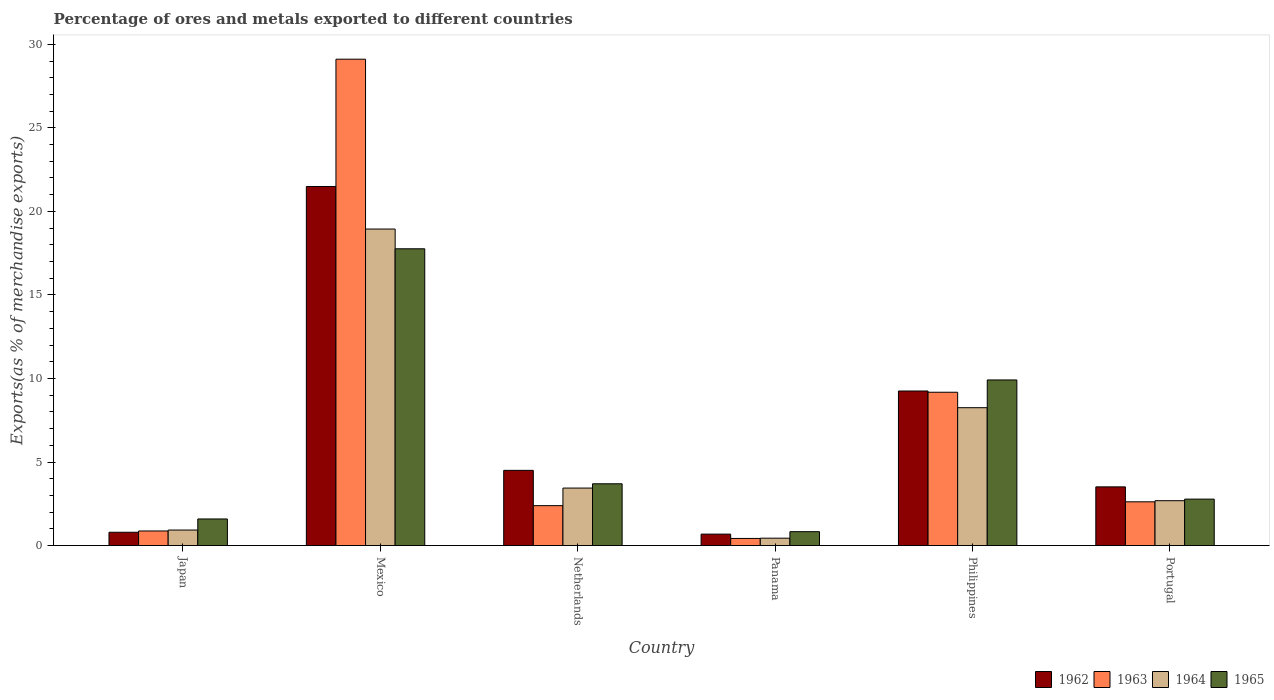How many groups of bars are there?
Make the answer very short. 6. Are the number of bars per tick equal to the number of legend labels?
Provide a short and direct response. Yes. How many bars are there on the 1st tick from the left?
Offer a terse response. 4. How many bars are there on the 5th tick from the right?
Make the answer very short. 4. In how many cases, is the number of bars for a given country not equal to the number of legend labels?
Make the answer very short. 0. What is the percentage of exports to different countries in 1962 in Panama?
Give a very brief answer. 0.69. Across all countries, what is the maximum percentage of exports to different countries in 1963?
Offer a very short reply. 29.11. Across all countries, what is the minimum percentage of exports to different countries in 1964?
Give a very brief answer. 0.44. In which country was the percentage of exports to different countries in 1965 minimum?
Provide a succinct answer. Panama. What is the total percentage of exports to different countries in 1963 in the graph?
Your response must be concise. 44.59. What is the difference between the percentage of exports to different countries in 1964 in Mexico and that in Portugal?
Your answer should be compact. 16.26. What is the difference between the percentage of exports to different countries in 1965 in Philippines and the percentage of exports to different countries in 1962 in Portugal?
Provide a short and direct response. 6.4. What is the average percentage of exports to different countries in 1965 per country?
Your response must be concise. 6.1. What is the difference between the percentage of exports to different countries of/in 1964 and percentage of exports to different countries of/in 1963 in Japan?
Keep it short and to the point. 0.06. What is the ratio of the percentage of exports to different countries in 1962 in Japan to that in Philippines?
Provide a succinct answer. 0.09. What is the difference between the highest and the second highest percentage of exports to different countries in 1965?
Your response must be concise. 14.06. What is the difference between the highest and the lowest percentage of exports to different countries in 1965?
Your answer should be very brief. 16.93. Is the sum of the percentage of exports to different countries in 1962 in Mexico and Netherlands greater than the maximum percentage of exports to different countries in 1965 across all countries?
Offer a very short reply. Yes. What does the 3rd bar from the left in Japan represents?
Provide a short and direct response. 1964. What does the 3rd bar from the right in Netherlands represents?
Your answer should be compact. 1963. Is it the case that in every country, the sum of the percentage of exports to different countries in 1962 and percentage of exports to different countries in 1963 is greater than the percentage of exports to different countries in 1965?
Provide a succinct answer. Yes. How many countries are there in the graph?
Give a very brief answer. 6. What is the difference between two consecutive major ticks on the Y-axis?
Ensure brevity in your answer.  5. Does the graph contain any zero values?
Make the answer very short. No. Does the graph contain grids?
Provide a short and direct response. No. What is the title of the graph?
Ensure brevity in your answer.  Percentage of ores and metals exported to different countries. Does "2014" appear as one of the legend labels in the graph?
Give a very brief answer. No. What is the label or title of the Y-axis?
Ensure brevity in your answer.  Exports(as % of merchandise exports). What is the Exports(as % of merchandise exports) in 1962 in Japan?
Provide a short and direct response. 0.8. What is the Exports(as % of merchandise exports) in 1963 in Japan?
Make the answer very short. 0.87. What is the Exports(as % of merchandise exports) of 1964 in Japan?
Your answer should be compact. 0.93. What is the Exports(as % of merchandise exports) in 1965 in Japan?
Provide a short and direct response. 1.59. What is the Exports(as % of merchandise exports) in 1962 in Mexico?
Provide a short and direct response. 21.49. What is the Exports(as % of merchandise exports) of 1963 in Mexico?
Your answer should be compact. 29.11. What is the Exports(as % of merchandise exports) of 1964 in Mexico?
Offer a very short reply. 18.94. What is the Exports(as % of merchandise exports) of 1965 in Mexico?
Provide a succinct answer. 17.76. What is the Exports(as % of merchandise exports) of 1962 in Netherlands?
Ensure brevity in your answer.  4.5. What is the Exports(as % of merchandise exports) of 1963 in Netherlands?
Offer a terse response. 2.39. What is the Exports(as % of merchandise exports) in 1964 in Netherlands?
Provide a succinct answer. 3.44. What is the Exports(as % of merchandise exports) in 1965 in Netherlands?
Offer a very short reply. 3.7. What is the Exports(as % of merchandise exports) of 1962 in Panama?
Offer a very short reply. 0.69. What is the Exports(as % of merchandise exports) in 1963 in Panama?
Provide a short and direct response. 0.43. What is the Exports(as % of merchandise exports) in 1964 in Panama?
Make the answer very short. 0.44. What is the Exports(as % of merchandise exports) in 1965 in Panama?
Offer a very short reply. 0.83. What is the Exports(as % of merchandise exports) of 1962 in Philippines?
Give a very brief answer. 9.25. What is the Exports(as % of merchandise exports) in 1963 in Philippines?
Your response must be concise. 9.18. What is the Exports(as % of merchandise exports) of 1964 in Philippines?
Offer a terse response. 8.25. What is the Exports(as % of merchandise exports) of 1965 in Philippines?
Your response must be concise. 9.91. What is the Exports(as % of merchandise exports) in 1962 in Portugal?
Give a very brief answer. 3.51. What is the Exports(as % of merchandise exports) of 1963 in Portugal?
Give a very brief answer. 2.62. What is the Exports(as % of merchandise exports) of 1964 in Portugal?
Make the answer very short. 2.69. What is the Exports(as % of merchandise exports) in 1965 in Portugal?
Provide a short and direct response. 2.78. Across all countries, what is the maximum Exports(as % of merchandise exports) of 1962?
Ensure brevity in your answer.  21.49. Across all countries, what is the maximum Exports(as % of merchandise exports) of 1963?
Your answer should be very brief. 29.11. Across all countries, what is the maximum Exports(as % of merchandise exports) of 1964?
Your answer should be very brief. 18.94. Across all countries, what is the maximum Exports(as % of merchandise exports) in 1965?
Offer a terse response. 17.76. Across all countries, what is the minimum Exports(as % of merchandise exports) of 1962?
Offer a very short reply. 0.69. Across all countries, what is the minimum Exports(as % of merchandise exports) of 1963?
Offer a very short reply. 0.43. Across all countries, what is the minimum Exports(as % of merchandise exports) of 1964?
Give a very brief answer. 0.44. Across all countries, what is the minimum Exports(as % of merchandise exports) in 1965?
Provide a short and direct response. 0.83. What is the total Exports(as % of merchandise exports) of 1962 in the graph?
Ensure brevity in your answer.  40.24. What is the total Exports(as % of merchandise exports) of 1963 in the graph?
Your response must be concise. 44.59. What is the total Exports(as % of merchandise exports) in 1964 in the graph?
Your answer should be compact. 34.69. What is the total Exports(as % of merchandise exports) of 1965 in the graph?
Make the answer very short. 36.57. What is the difference between the Exports(as % of merchandise exports) in 1962 in Japan and that in Mexico?
Provide a succinct answer. -20.69. What is the difference between the Exports(as % of merchandise exports) in 1963 in Japan and that in Mexico?
Ensure brevity in your answer.  -28.24. What is the difference between the Exports(as % of merchandise exports) of 1964 in Japan and that in Mexico?
Ensure brevity in your answer.  -18.01. What is the difference between the Exports(as % of merchandise exports) in 1965 in Japan and that in Mexico?
Your answer should be compact. -16.17. What is the difference between the Exports(as % of merchandise exports) in 1962 in Japan and that in Netherlands?
Give a very brief answer. -3.7. What is the difference between the Exports(as % of merchandise exports) in 1963 in Japan and that in Netherlands?
Give a very brief answer. -1.52. What is the difference between the Exports(as % of merchandise exports) of 1964 in Japan and that in Netherlands?
Your answer should be compact. -2.51. What is the difference between the Exports(as % of merchandise exports) in 1965 in Japan and that in Netherlands?
Make the answer very short. -2.11. What is the difference between the Exports(as % of merchandise exports) in 1962 in Japan and that in Panama?
Ensure brevity in your answer.  0.11. What is the difference between the Exports(as % of merchandise exports) of 1963 in Japan and that in Panama?
Give a very brief answer. 0.45. What is the difference between the Exports(as % of merchandise exports) in 1964 in Japan and that in Panama?
Provide a short and direct response. 0.49. What is the difference between the Exports(as % of merchandise exports) of 1965 in Japan and that in Panama?
Make the answer very short. 0.76. What is the difference between the Exports(as % of merchandise exports) in 1962 in Japan and that in Philippines?
Provide a short and direct response. -8.45. What is the difference between the Exports(as % of merchandise exports) in 1963 in Japan and that in Philippines?
Keep it short and to the point. -8.3. What is the difference between the Exports(as % of merchandise exports) of 1964 in Japan and that in Philippines?
Offer a terse response. -7.32. What is the difference between the Exports(as % of merchandise exports) of 1965 in Japan and that in Philippines?
Offer a very short reply. -8.32. What is the difference between the Exports(as % of merchandise exports) of 1962 in Japan and that in Portugal?
Your answer should be compact. -2.72. What is the difference between the Exports(as % of merchandise exports) of 1963 in Japan and that in Portugal?
Give a very brief answer. -1.75. What is the difference between the Exports(as % of merchandise exports) of 1964 in Japan and that in Portugal?
Offer a very short reply. -1.76. What is the difference between the Exports(as % of merchandise exports) in 1965 in Japan and that in Portugal?
Keep it short and to the point. -1.19. What is the difference between the Exports(as % of merchandise exports) of 1962 in Mexico and that in Netherlands?
Give a very brief answer. 16.99. What is the difference between the Exports(as % of merchandise exports) in 1963 in Mexico and that in Netherlands?
Provide a succinct answer. 26.72. What is the difference between the Exports(as % of merchandise exports) in 1964 in Mexico and that in Netherlands?
Offer a very short reply. 15.5. What is the difference between the Exports(as % of merchandise exports) of 1965 in Mexico and that in Netherlands?
Provide a succinct answer. 14.06. What is the difference between the Exports(as % of merchandise exports) in 1962 in Mexico and that in Panama?
Offer a very short reply. 20.81. What is the difference between the Exports(as % of merchandise exports) in 1963 in Mexico and that in Panama?
Ensure brevity in your answer.  28.68. What is the difference between the Exports(as % of merchandise exports) in 1964 in Mexico and that in Panama?
Ensure brevity in your answer.  18.5. What is the difference between the Exports(as % of merchandise exports) of 1965 in Mexico and that in Panama?
Your answer should be very brief. 16.93. What is the difference between the Exports(as % of merchandise exports) in 1962 in Mexico and that in Philippines?
Your answer should be compact. 12.24. What is the difference between the Exports(as % of merchandise exports) in 1963 in Mexico and that in Philippines?
Ensure brevity in your answer.  19.93. What is the difference between the Exports(as % of merchandise exports) of 1964 in Mexico and that in Philippines?
Offer a very short reply. 10.69. What is the difference between the Exports(as % of merchandise exports) in 1965 in Mexico and that in Philippines?
Your response must be concise. 7.85. What is the difference between the Exports(as % of merchandise exports) in 1962 in Mexico and that in Portugal?
Provide a succinct answer. 17.98. What is the difference between the Exports(as % of merchandise exports) of 1963 in Mexico and that in Portugal?
Keep it short and to the point. 26.49. What is the difference between the Exports(as % of merchandise exports) of 1964 in Mexico and that in Portugal?
Offer a terse response. 16.26. What is the difference between the Exports(as % of merchandise exports) of 1965 in Mexico and that in Portugal?
Offer a terse response. 14.98. What is the difference between the Exports(as % of merchandise exports) in 1962 in Netherlands and that in Panama?
Your answer should be compact. 3.82. What is the difference between the Exports(as % of merchandise exports) of 1963 in Netherlands and that in Panama?
Offer a very short reply. 1.96. What is the difference between the Exports(as % of merchandise exports) in 1964 in Netherlands and that in Panama?
Provide a short and direct response. 3. What is the difference between the Exports(as % of merchandise exports) of 1965 in Netherlands and that in Panama?
Make the answer very short. 2.87. What is the difference between the Exports(as % of merchandise exports) of 1962 in Netherlands and that in Philippines?
Your answer should be very brief. -4.75. What is the difference between the Exports(as % of merchandise exports) of 1963 in Netherlands and that in Philippines?
Keep it short and to the point. -6.79. What is the difference between the Exports(as % of merchandise exports) of 1964 in Netherlands and that in Philippines?
Your answer should be very brief. -4.81. What is the difference between the Exports(as % of merchandise exports) in 1965 in Netherlands and that in Philippines?
Keep it short and to the point. -6.21. What is the difference between the Exports(as % of merchandise exports) of 1962 in Netherlands and that in Portugal?
Provide a succinct answer. 0.99. What is the difference between the Exports(as % of merchandise exports) of 1963 in Netherlands and that in Portugal?
Ensure brevity in your answer.  -0.23. What is the difference between the Exports(as % of merchandise exports) in 1964 in Netherlands and that in Portugal?
Offer a very short reply. 0.76. What is the difference between the Exports(as % of merchandise exports) in 1965 in Netherlands and that in Portugal?
Ensure brevity in your answer.  0.92. What is the difference between the Exports(as % of merchandise exports) of 1962 in Panama and that in Philippines?
Your response must be concise. -8.56. What is the difference between the Exports(as % of merchandise exports) in 1963 in Panama and that in Philippines?
Keep it short and to the point. -8.75. What is the difference between the Exports(as % of merchandise exports) of 1964 in Panama and that in Philippines?
Your answer should be very brief. -7.81. What is the difference between the Exports(as % of merchandise exports) of 1965 in Panama and that in Philippines?
Provide a succinct answer. -9.08. What is the difference between the Exports(as % of merchandise exports) of 1962 in Panama and that in Portugal?
Your answer should be compact. -2.83. What is the difference between the Exports(as % of merchandise exports) of 1963 in Panama and that in Portugal?
Your answer should be compact. -2.19. What is the difference between the Exports(as % of merchandise exports) of 1964 in Panama and that in Portugal?
Your answer should be compact. -2.24. What is the difference between the Exports(as % of merchandise exports) in 1965 in Panama and that in Portugal?
Your answer should be compact. -1.95. What is the difference between the Exports(as % of merchandise exports) in 1962 in Philippines and that in Portugal?
Keep it short and to the point. 5.74. What is the difference between the Exports(as % of merchandise exports) in 1963 in Philippines and that in Portugal?
Offer a terse response. 6.56. What is the difference between the Exports(as % of merchandise exports) in 1964 in Philippines and that in Portugal?
Your response must be concise. 5.57. What is the difference between the Exports(as % of merchandise exports) of 1965 in Philippines and that in Portugal?
Provide a succinct answer. 7.13. What is the difference between the Exports(as % of merchandise exports) of 1962 in Japan and the Exports(as % of merchandise exports) of 1963 in Mexico?
Ensure brevity in your answer.  -28.31. What is the difference between the Exports(as % of merchandise exports) in 1962 in Japan and the Exports(as % of merchandise exports) in 1964 in Mexico?
Your response must be concise. -18.15. What is the difference between the Exports(as % of merchandise exports) in 1962 in Japan and the Exports(as % of merchandise exports) in 1965 in Mexico?
Your answer should be very brief. -16.97. What is the difference between the Exports(as % of merchandise exports) in 1963 in Japan and the Exports(as % of merchandise exports) in 1964 in Mexico?
Your answer should be very brief. -18.07. What is the difference between the Exports(as % of merchandise exports) of 1963 in Japan and the Exports(as % of merchandise exports) of 1965 in Mexico?
Your answer should be very brief. -16.89. What is the difference between the Exports(as % of merchandise exports) of 1964 in Japan and the Exports(as % of merchandise exports) of 1965 in Mexico?
Ensure brevity in your answer.  -16.83. What is the difference between the Exports(as % of merchandise exports) of 1962 in Japan and the Exports(as % of merchandise exports) of 1963 in Netherlands?
Your answer should be compact. -1.59. What is the difference between the Exports(as % of merchandise exports) in 1962 in Japan and the Exports(as % of merchandise exports) in 1964 in Netherlands?
Make the answer very short. -2.64. What is the difference between the Exports(as % of merchandise exports) of 1962 in Japan and the Exports(as % of merchandise exports) of 1965 in Netherlands?
Keep it short and to the point. -2.9. What is the difference between the Exports(as % of merchandise exports) in 1963 in Japan and the Exports(as % of merchandise exports) in 1964 in Netherlands?
Give a very brief answer. -2.57. What is the difference between the Exports(as % of merchandise exports) of 1963 in Japan and the Exports(as % of merchandise exports) of 1965 in Netherlands?
Your answer should be compact. -2.82. What is the difference between the Exports(as % of merchandise exports) in 1964 in Japan and the Exports(as % of merchandise exports) in 1965 in Netherlands?
Offer a very short reply. -2.77. What is the difference between the Exports(as % of merchandise exports) in 1962 in Japan and the Exports(as % of merchandise exports) in 1963 in Panama?
Provide a succinct answer. 0.37. What is the difference between the Exports(as % of merchandise exports) in 1962 in Japan and the Exports(as % of merchandise exports) in 1964 in Panama?
Provide a succinct answer. 0.35. What is the difference between the Exports(as % of merchandise exports) of 1962 in Japan and the Exports(as % of merchandise exports) of 1965 in Panama?
Your response must be concise. -0.03. What is the difference between the Exports(as % of merchandise exports) in 1963 in Japan and the Exports(as % of merchandise exports) in 1964 in Panama?
Provide a succinct answer. 0.43. What is the difference between the Exports(as % of merchandise exports) in 1963 in Japan and the Exports(as % of merchandise exports) in 1965 in Panama?
Provide a succinct answer. 0.04. What is the difference between the Exports(as % of merchandise exports) in 1964 in Japan and the Exports(as % of merchandise exports) in 1965 in Panama?
Ensure brevity in your answer.  0.1. What is the difference between the Exports(as % of merchandise exports) of 1962 in Japan and the Exports(as % of merchandise exports) of 1963 in Philippines?
Offer a very short reply. -8.38. What is the difference between the Exports(as % of merchandise exports) in 1962 in Japan and the Exports(as % of merchandise exports) in 1964 in Philippines?
Offer a terse response. -7.46. What is the difference between the Exports(as % of merchandise exports) of 1962 in Japan and the Exports(as % of merchandise exports) of 1965 in Philippines?
Give a very brief answer. -9.12. What is the difference between the Exports(as % of merchandise exports) of 1963 in Japan and the Exports(as % of merchandise exports) of 1964 in Philippines?
Your answer should be very brief. -7.38. What is the difference between the Exports(as % of merchandise exports) in 1963 in Japan and the Exports(as % of merchandise exports) in 1965 in Philippines?
Make the answer very short. -9.04. What is the difference between the Exports(as % of merchandise exports) of 1964 in Japan and the Exports(as % of merchandise exports) of 1965 in Philippines?
Provide a succinct answer. -8.98. What is the difference between the Exports(as % of merchandise exports) in 1962 in Japan and the Exports(as % of merchandise exports) in 1963 in Portugal?
Provide a short and direct response. -1.82. What is the difference between the Exports(as % of merchandise exports) in 1962 in Japan and the Exports(as % of merchandise exports) in 1964 in Portugal?
Give a very brief answer. -1.89. What is the difference between the Exports(as % of merchandise exports) of 1962 in Japan and the Exports(as % of merchandise exports) of 1965 in Portugal?
Make the answer very short. -1.98. What is the difference between the Exports(as % of merchandise exports) of 1963 in Japan and the Exports(as % of merchandise exports) of 1964 in Portugal?
Provide a succinct answer. -1.81. What is the difference between the Exports(as % of merchandise exports) in 1963 in Japan and the Exports(as % of merchandise exports) in 1965 in Portugal?
Ensure brevity in your answer.  -1.91. What is the difference between the Exports(as % of merchandise exports) in 1964 in Japan and the Exports(as % of merchandise exports) in 1965 in Portugal?
Provide a short and direct response. -1.85. What is the difference between the Exports(as % of merchandise exports) of 1962 in Mexico and the Exports(as % of merchandise exports) of 1963 in Netherlands?
Ensure brevity in your answer.  19.1. What is the difference between the Exports(as % of merchandise exports) in 1962 in Mexico and the Exports(as % of merchandise exports) in 1964 in Netherlands?
Make the answer very short. 18.05. What is the difference between the Exports(as % of merchandise exports) of 1962 in Mexico and the Exports(as % of merchandise exports) of 1965 in Netherlands?
Your answer should be compact. 17.79. What is the difference between the Exports(as % of merchandise exports) in 1963 in Mexico and the Exports(as % of merchandise exports) in 1964 in Netherlands?
Your answer should be very brief. 25.67. What is the difference between the Exports(as % of merchandise exports) in 1963 in Mexico and the Exports(as % of merchandise exports) in 1965 in Netherlands?
Make the answer very short. 25.41. What is the difference between the Exports(as % of merchandise exports) in 1964 in Mexico and the Exports(as % of merchandise exports) in 1965 in Netherlands?
Your answer should be compact. 15.25. What is the difference between the Exports(as % of merchandise exports) in 1962 in Mexico and the Exports(as % of merchandise exports) in 1963 in Panama?
Provide a short and direct response. 21.06. What is the difference between the Exports(as % of merchandise exports) in 1962 in Mexico and the Exports(as % of merchandise exports) in 1964 in Panama?
Offer a terse response. 21.05. What is the difference between the Exports(as % of merchandise exports) of 1962 in Mexico and the Exports(as % of merchandise exports) of 1965 in Panama?
Ensure brevity in your answer.  20.66. What is the difference between the Exports(as % of merchandise exports) of 1963 in Mexico and the Exports(as % of merchandise exports) of 1964 in Panama?
Your response must be concise. 28.67. What is the difference between the Exports(as % of merchandise exports) of 1963 in Mexico and the Exports(as % of merchandise exports) of 1965 in Panama?
Your response must be concise. 28.28. What is the difference between the Exports(as % of merchandise exports) in 1964 in Mexico and the Exports(as % of merchandise exports) in 1965 in Panama?
Offer a very short reply. 18.11. What is the difference between the Exports(as % of merchandise exports) in 1962 in Mexico and the Exports(as % of merchandise exports) in 1963 in Philippines?
Your answer should be very brief. 12.31. What is the difference between the Exports(as % of merchandise exports) in 1962 in Mexico and the Exports(as % of merchandise exports) in 1964 in Philippines?
Provide a succinct answer. 13.24. What is the difference between the Exports(as % of merchandise exports) in 1962 in Mexico and the Exports(as % of merchandise exports) in 1965 in Philippines?
Offer a terse response. 11.58. What is the difference between the Exports(as % of merchandise exports) of 1963 in Mexico and the Exports(as % of merchandise exports) of 1964 in Philippines?
Offer a terse response. 20.86. What is the difference between the Exports(as % of merchandise exports) in 1963 in Mexico and the Exports(as % of merchandise exports) in 1965 in Philippines?
Your answer should be compact. 19.2. What is the difference between the Exports(as % of merchandise exports) in 1964 in Mexico and the Exports(as % of merchandise exports) in 1965 in Philippines?
Ensure brevity in your answer.  9.03. What is the difference between the Exports(as % of merchandise exports) in 1962 in Mexico and the Exports(as % of merchandise exports) in 1963 in Portugal?
Offer a terse response. 18.87. What is the difference between the Exports(as % of merchandise exports) of 1962 in Mexico and the Exports(as % of merchandise exports) of 1964 in Portugal?
Ensure brevity in your answer.  18.81. What is the difference between the Exports(as % of merchandise exports) in 1962 in Mexico and the Exports(as % of merchandise exports) in 1965 in Portugal?
Make the answer very short. 18.71. What is the difference between the Exports(as % of merchandise exports) in 1963 in Mexico and the Exports(as % of merchandise exports) in 1964 in Portugal?
Make the answer very short. 26.42. What is the difference between the Exports(as % of merchandise exports) in 1963 in Mexico and the Exports(as % of merchandise exports) in 1965 in Portugal?
Your answer should be compact. 26.33. What is the difference between the Exports(as % of merchandise exports) of 1964 in Mexico and the Exports(as % of merchandise exports) of 1965 in Portugal?
Your answer should be compact. 16.16. What is the difference between the Exports(as % of merchandise exports) of 1962 in Netherlands and the Exports(as % of merchandise exports) of 1963 in Panama?
Provide a succinct answer. 4.07. What is the difference between the Exports(as % of merchandise exports) of 1962 in Netherlands and the Exports(as % of merchandise exports) of 1964 in Panama?
Provide a short and direct response. 4.06. What is the difference between the Exports(as % of merchandise exports) of 1962 in Netherlands and the Exports(as % of merchandise exports) of 1965 in Panama?
Provide a succinct answer. 3.67. What is the difference between the Exports(as % of merchandise exports) of 1963 in Netherlands and the Exports(as % of merchandise exports) of 1964 in Panama?
Ensure brevity in your answer.  1.95. What is the difference between the Exports(as % of merchandise exports) in 1963 in Netherlands and the Exports(as % of merchandise exports) in 1965 in Panama?
Offer a very short reply. 1.56. What is the difference between the Exports(as % of merchandise exports) in 1964 in Netherlands and the Exports(as % of merchandise exports) in 1965 in Panama?
Keep it short and to the point. 2.61. What is the difference between the Exports(as % of merchandise exports) of 1962 in Netherlands and the Exports(as % of merchandise exports) of 1963 in Philippines?
Your answer should be very brief. -4.67. What is the difference between the Exports(as % of merchandise exports) in 1962 in Netherlands and the Exports(as % of merchandise exports) in 1964 in Philippines?
Your answer should be compact. -3.75. What is the difference between the Exports(as % of merchandise exports) of 1962 in Netherlands and the Exports(as % of merchandise exports) of 1965 in Philippines?
Make the answer very short. -5.41. What is the difference between the Exports(as % of merchandise exports) of 1963 in Netherlands and the Exports(as % of merchandise exports) of 1964 in Philippines?
Your answer should be compact. -5.86. What is the difference between the Exports(as % of merchandise exports) of 1963 in Netherlands and the Exports(as % of merchandise exports) of 1965 in Philippines?
Your answer should be compact. -7.52. What is the difference between the Exports(as % of merchandise exports) of 1964 in Netherlands and the Exports(as % of merchandise exports) of 1965 in Philippines?
Provide a short and direct response. -6.47. What is the difference between the Exports(as % of merchandise exports) of 1962 in Netherlands and the Exports(as % of merchandise exports) of 1963 in Portugal?
Provide a succinct answer. 1.88. What is the difference between the Exports(as % of merchandise exports) of 1962 in Netherlands and the Exports(as % of merchandise exports) of 1964 in Portugal?
Offer a terse response. 1.82. What is the difference between the Exports(as % of merchandise exports) of 1962 in Netherlands and the Exports(as % of merchandise exports) of 1965 in Portugal?
Give a very brief answer. 1.72. What is the difference between the Exports(as % of merchandise exports) of 1963 in Netherlands and the Exports(as % of merchandise exports) of 1964 in Portugal?
Give a very brief answer. -0.3. What is the difference between the Exports(as % of merchandise exports) of 1963 in Netherlands and the Exports(as % of merchandise exports) of 1965 in Portugal?
Your answer should be compact. -0.39. What is the difference between the Exports(as % of merchandise exports) in 1964 in Netherlands and the Exports(as % of merchandise exports) in 1965 in Portugal?
Keep it short and to the point. 0.66. What is the difference between the Exports(as % of merchandise exports) of 1962 in Panama and the Exports(as % of merchandise exports) of 1963 in Philippines?
Make the answer very short. -8.49. What is the difference between the Exports(as % of merchandise exports) of 1962 in Panama and the Exports(as % of merchandise exports) of 1964 in Philippines?
Make the answer very short. -7.57. What is the difference between the Exports(as % of merchandise exports) in 1962 in Panama and the Exports(as % of merchandise exports) in 1965 in Philippines?
Offer a terse response. -9.23. What is the difference between the Exports(as % of merchandise exports) in 1963 in Panama and the Exports(as % of merchandise exports) in 1964 in Philippines?
Provide a short and direct response. -7.83. What is the difference between the Exports(as % of merchandise exports) of 1963 in Panama and the Exports(as % of merchandise exports) of 1965 in Philippines?
Offer a very short reply. -9.49. What is the difference between the Exports(as % of merchandise exports) in 1964 in Panama and the Exports(as % of merchandise exports) in 1965 in Philippines?
Your answer should be very brief. -9.47. What is the difference between the Exports(as % of merchandise exports) of 1962 in Panama and the Exports(as % of merchandise exports) of 1963 in Portugal?
Your response must be concise. -1.93. What is the difference between the Exports(as % of merchandise exports) in 1962 in Panama and the Exports(as % of merchandise exports) in 1964 in Portugal?
Offer a terse response. -2. What is the difference between the Exports(as % of merchandise exports) in 1962 in Panama and the Exports(as % of merchandise exports) in 1965 in Portugal?
Your answer should be compact. -2.09. What is the difference between the Exports(as % of merchandise exports) in 1963 in Panama and the Exports(as % of merchandise exports) in 1964 in Portugal?
Keep it short and to the point. -2.26. What is the difference between the Exports(as % of merchandise exports) of 1963 in Panama and the Exports(as % of merchandise exports) of 1965 in Portugal?
Offer a terse response. -2.35. What is the difference between the Exports(as % of merchandise exports) of 1964 in Panama and the Exports(as % of merchandise exports) of 1965 in Portugal?
Provide a short and direct response. -2.34. What is the difference between the Exports(as % of merchandise exports) in 1962 in Philippines and the Exports(as % of merchandise exports) in 1963 in Portugal?
Provide a succinct answer. 6.63. What is the difference between the Exports(as % of merchandise exports) in 1962 in Philippines and the Exports(as % of merchandise exports) in 1964 in Portugal?
Provide a succinct answer. 6.56. What is the difference between the Exports(as % of merchandise exports) in 1962 in Philippines and the Exports(as % of merchandise exports) in 1965 in Portugal?
Offer a terse response. 6.47. What is the difference between the Exports(as % of merchandise exports) of 1963 in Philippines and the Exports(as % of merchandise exports) of 1964 in Portugal?
Provide a short and direct response. 6.49. What is the difference between the Exports(as % of merchandise exports) in 1963 in Philippines and the Exports(as % of merchandise exports) in 1965 in Portugal?
Give a very brief answer. 6.4. What is the difference between the Exports(as % of merchandise exports) of 1964 in Philippines and the Exports(as % of merchandise exports) of 1965 in Portugal?
Your answer should be compact. 5.47. What is the average Exports(as % of merchandise exports) in 1962 per country?
Provide a succinct answer. 6.71. What is the average Exports(as % of merchandise exports) of 1963 per country?
Your answer should be compact. 7.43. What is the average Exports(as % of merchandise exports) of 1964 per country?
Give a very brief answer. 5.78. What is the average Exports(as % of merchandise exports) in 1965 per country?
Offer a very short reply. 6.1. What is the difference between the Exports(as % of merchandise exports) in 1962 and Exports(as % of merchandise exports) in 1963 in Japan?
Your answer should be compact. -0.08. What is the difference between the Exports(as % of merchandise exports) of 1962 and Exports(as % of merchandise exports) of 1964 in Japan?
Offer a terse response. -0.13. What is the difference between the Exports(as % of merchandise exports) in 1962 and Exports(as % of merchandise exports) in 1965 in Japan?
Your response must be concise. -0.8. What is the difference between the Exports(as % of merchandise exports) of 1963 and Exports(as % of merchandise exports) of 1964 in Japan?
Make the answer very short. -0.06. What is the difference between the Exports(as % of merchandise exports) of 1963 and Exports(as % of merchandise exports) of 1965 in Japan?
Provide a succinct answer. -0.72. What is the difference between the Exports(as % of merchandise exports) of 1964 and Exports(as % of merchandise exports) of 1965 in Japan?
Your answer should be compact. -0.66. What is the difference between the Exports(as % of merchandise exports) of 1962 and Exports(as % of merchandise exports) of 1963 in Mexico?
Offer a terse response. -7.62. What is the difference between the Exports(as % of merchandise exports) in 1962 and Exports(as % of merchandise exports) in 1964 in Mexico?
Provide a short and direct response. 2.55. What is the difference between the Exports(as % of merchandise exports) of 1962 and Exports(as % of merchandise exports) of 1965 in Mexico?
Offer a very short reply. 3.73. What is the difference between the Exports(as % of merchandise exports) in 1963 and Exports(as % of merchandise exports) in 1964 in Mexico?
Provide a succinct answer. 10.16. What is the difference between the Exports(as % of merchandise exports) of 1963 and Exports(as % of merchandise exports) of 1965 in Mexico?
Keep it short and to the point. 11.35. What is the difference between the Exports(as % of merchandise exports) in 1964 and Exports(as % of merchandise exports) in 1965 in Mexico?
Provide a succinct answer. 1.18. What is the difference between the Exports(as % of merchandise exports) of 1962 and Exports(as % of merchandise exports) of 1963 in Netherlands?
Provide a short and direct response. 2.11. What is the difference between the Exports(as % of merchandise exports) of 1962 and Exports(as % of merchandise exports) of 1964 in Netherlands?
Provide a succinct answer. 1.06. What is the difference between the Exports(as % of merchandise exports) in 1962 and Exports(as % of merchandise exports) in 1965 in Netherlands?
Offer a very short reply. 0.8. What is the difference between the Exports(as % of merchandise exports) of 1963 and Exports(as % of merchandise exports) of 1964 in Netherlands?
Your answer should be very brief. -1.05. What is the difference between the Exports(as % of merchandise exports) in 1963 and Exports(as % of merchandise exports) in 1965 in Netherlands?
Provide a succinct answer. -1.31. What is the difference between the Exports(as % of merchandise exports) of 1964 and Exports(as % of merchandise exports) of 1965 in Netherlands?
Offer a terse response. -0.26. What is the difference between the Exports(as % of merchandise exports) in 1962 and Exports(as % of merchandise exports) in 1963 in Panama?
Your answer should be compact. 0.26. What is the difference between the Exports(as % of merchandise exports) in 1962 and Exports(as % of merchandise exports) in 1964 in Panama?
Your response must be concise. 0.24. What is the difference between the Exports(as % of merchandise exports) in 1962 and Exports(as % of merchandise exports) in 1965 in Panama?
Offer a very short reply. -0.15. What is the difference between the Exports(as % of merchandise exports) in 1963 and Exports(as % of merchandise exports) in 1964 in Panama?
Provide a succinct answer. -0.02. What is the difference between the Exports(as % of merchandise exports) of 1963 and Exports(as % of merchandise exports) of 1965 in Panama?
Your response must be concise. -0.4. What is the difference between the Exports(as % of merchandise exports) of 1964 and Exports(as % of merchandise exports) of 1965 in Panama?
Your answer should be very brief. -0.39. What is the difference between the Exports(as % of merchandise exports) in 1962 and Exports(as % of merchandise exports) in 1963 in Philippines?
Your response must be concise. 0.07. What is the difference between the Exports(as % of merchandise exports) of 1962 and Exports(as % of merchandise exports) of 1964 in Philippines?
Offer a very short reply. 1. What is the difference between the Exports(as % of merchandise exports) in 1962 and Exports(as % of merchandise exports) in 1965 in Philippines?
Your answer should be compact. -0.66. What is the difference between the Exports(as % of merchandise exports) of 1963 and Exports(as % of merchandise exports) of 1964 in Philippines?
Offer a very short reply. 0.92. What is the difference between the Exports(as % of merchandise exports) of 1963 and Exports(as % of merchandise exports) of 1965 in Philippines?
Make the answer very short. -0.74. What is the difference between the Exports(as % of merchandise exports) of 1964 and Exports(as % of merchandise exports) of 1965 in Philippines?
Provide a short and direct response. -1.66. What is the difference between the Exports(as % of merchandise exports) in 1962 and Exports(as % of merchandise exports) in 1963 in Portugal?
Ensure brevity in your answer.  0.89. What is the difference between the Exports(as % of merchandise exports) in 1962 and Exports(as % of merchandise exports) in 1964 in Portugal?
Keep it short and to the point. 0.83. What is the difference between the Exports(as % of merchandise exports) of 1962 and Exports(as % of merchandise exports) of 1965 in Portugal?
Give a very brief answer. 0.73. What is the difference between the Exports(as % of merchandise exports) in 1963 and Exports(as % of merchandise exports) in 1964 in Portugal?
Your response must be concise. -0.07. What is the difference between the Exports(as % of merchandise exports) in 1963 and Exports(as % of merchandise exports) in 1965 in Portugal?
Offer a very short reply. -0.16. What is the difference between the Exports(as % of merchandise exports) of 1964 and Exports(as % of merchandise exports) of 1965 in Portugal?
Keep it short and to the point. -0.09. What is the ratio of the Exports(as % of merchandise exports) of 1962 in Japan to that in Mexico?
Your response must be concise. 0.04. What is the ratio of the Exports(as % of merchandise exports) in 1963 in Japan to that in Mexico?
Provide a succinct answer. 0.03. What is the ratio of the Exports(as % of merchandise exports) in 1964 in Japan to that in Mexico?
Make the answer very short. 0.05. What is the ratio of the Exports(as % of merchandise exports) in 1965 in Japan to that in Mexico?
Your answer should be compact. 0.09. What is the ratio of the Exports(as % of merchandise exports) of 1962 in Japan to that in Netherlands?
Ensure brevity in your answer.  0.18. What is the ratio of the Exports(as % of merchandise exports) in 1963 in Japan to that in Netherlands?
Give a very brief answer. 0.37. What is the ratio of the Exports(as % of merchandise exports) of 1964 in Japan to that in Netherlands?
Your response must be concise. 0.27. What is the ratio of the Exports(as % of merchandise exports) in 1965 in Japan to that in Netherlands?
Your answer should be very brief. 0.43. What is the ratio of the Exports(as % of merchandise exports) of 1962 in Japan to that in Panama?
Make the answer very short. 1.16. What is the ratio of the Exports(as % of merchandise exports) in 1963 in Japan to that in Panama?
Provide a short and direct response. 2.05. What is the ratio of the Exports(as % of merchandise exports) in 1964 in Japan to that in Panama?
Your answer should be compact. 2.1. What is the ratio of the Exports(as % of merchandise exports) in 1965 in Japan to that in Panama?
Offer a terse response. 1.92. What is the ratio of the Exports(as % of merchandise exports) in 1962 in Japan to that in Philippines?
Offer a terse response. 0.09. What is the ratio of the Exports(as % of merchandise exports) in 1963 in Japan to that in Philippines?
Your response must be concise. 0.1. What is the ratio of the Exports(as % of merchandise exports) of 1964 in Japan to that in Philippines?
Offer a very short reply. 0.11. What is the ratio of the Exports(as % of merchandise exports) in 1965 in Japan to that in Philippines?
Make the answer very short. 0.16. What is the ratio of the Exports(as % of merchandise exports) of 1962 in Japan to that in Portugal?
Ensure brevity in your answer.  0.23. What is the ratio of the Exports(as % of merchandise exports) of 1963 in Japan to that in Portugal?
Your response must be concise. 0.33. What is the ratio of the Exports(as % of merchandise exports) in 1964 in Japan to that in Portugal?
Your response must be concise. 0.35. What is the ratio of the Exports(as % of merchandise exports) of 1965 in Japan to that in Portugal?
Offer a very short reply. 0.57. What is the ratio of the Exports(as % of merchandise exports) in 1962 in Mexico to that in Netherlands?
Your answer should be compact. 4.77. What is the ratio of the Exports(as % of merchandise exports) in 1963 in Mexico to that in Netherlands?
Provide a succinct answer. 12.18. What is the ratio of the Exports(as % of merchandise exports) of 1964 in Mexico to that in Netherlands?
Make the answer very short. 5.51. What is the ratio of the Exports(as % of merchandise exports) in 1965 in Mexico to that in Netherlands?
Provide a succinct answer. 4.8. What is the ratio of the Exports(as % of merchandise exports) in 1962 in Mexico to that in Panama?
Provide a succinct answer. 31.37. What is the ratio of the Exports(as % of merchandise exports) of 1963 in Mexico to that in Panama?
Provide a succinct answer. 68.27. What is the ratio of the Exports(as % of merchandise exports) of 1964 in Mexico to that in Panama?
Offer a very short reply. 42.84. What is the ratio of the Exports(as % of merchandise exports) in 1965 in Mexico to that in Panama?
Give a very brief answer. 21.38. What is the ratio of the Exports(as % of merchandise exports) in 1962 in Mexico to that in Philippines?
Offer a terse response. 2.32. What is the ratio of the Exports(as % of merchandise exports) of 1963 in Mexico to that in Philippines?
Give a very brief answer. 3.17. What is the ratio of the Exports(as % of merchandise exports) in 1964 in Mexico to that in Philippines?
Provide a short and direct response. 2.3. What is the ratio of the Exports(as % of merchandise exports) in 1965 in Mexico to that in Philippines?
Provide a short and direct response. 1.79. What is the ratio of the Exports(as % of merchandise exports) in 1962 in Mexico to that in Portugal?
Make the answer very short. 6.12. What is the ratio of the Exports(as % of merchandise exports) of 1963 in Mexico to that in Portugal?
Your answer should be very brief. 11.12. What is the ratio of the Exports(as % of merchandise exports) in 1964 in Mexico to that in Portugal?
Ensure brevity in your answer.  7.05. What is the ratio of the Exports(as % of merchandise exports) of 1965 in Mexico to that in Portugal?
Provide a succinct answer. 6.39. What is the ratio of the Exports(as % of merchandise exports) of 1962 in Netherlands to that in Panama?
Ensure brevity in your answer.  6.57. What is the ratio of the Exports(as % of merchandise exports) of 1963 in Netherlands to that in Panama?
Offer a terse response. 5.6. What is the ratio of the Exports(as % of merchandise exports) of 1964 in Netherlands to that in Panama?
Your answer should be very brief. 7.78. What is the ratio of the Exports(as % of merchandise exports) of 1965 in Netherlands to that in Panama?
Offer a very short reply. 4.45. What is the ratio of the Exports(as % of merchandise exports) in 1962 in Netherlands to that in Philippines?
Give a very brief answer. 0.49. What is the ratio of the Exports(as % of merchandise exports) of 1963 in Netherlands to that in Philippines?
Ensure brevity in your answer.  0.26. What is the ratio of the Exports(as % of merchandise exports) of 1964 in Netherlands to that in Philippines?
Provide a short and direct response. 0.42. What is the ratio of the Exports(as % of merchandise exports) in 1965 in Netherlands to that in Philippines?
Your answer should be very brief. 0.37. What is the ratio of the Exports(as % of merchandise exports) of 1962 in Netherlands to that in Portugal?
Your response must be concise. 1.28. What is the ratio of the Exports(as % of merchandise exports) of 1963 in Netherlands to that in Portugal?
Keep it short and to the point. 0.91. What is the ratio of the Exports(as % of merchandise exports) in 1964 in Netherlands to that in Portugal?
Your answer should be compact. 1.28. What is the ratio of the Exports(as % of merchandise exports) in 1965 in Netherlands to that in Portugal?
Your answer should be very brief. 1.33. What is the ratio of the Exports(as % of merchandise exports) of 1962 in Panama to that in Philippines?
Provide a short and direct response. 0.07. What is the ratio of the Exports(as % of merchandise exports) of 1963 in Panama to that in Philippines?
Your answer should be very brief. 0.05. What is the ratio of the Exports(as % of merchandise exports) of 1964 in Panama to that in Philippines?
Make the answer very short. 0.05. What is the ratio of the Exports(as % of merchandise exports) in 1965 in Panama to that in Philippines?
Ensure brevity in your answer.  0.08. What is the ratio of the Exports(as % of merchandise exports) of 1962 in Panama to that in Portugal?
Your response must be concise. 0.2. What is the ratio of the Exports(as % of merchandise exports) in 1963 in Panama to that in Portugal?
Offer a terse response. 0.16. What is the ratio of the Exports(as % of merchandise exports) of 1964 in Panama to that in Portugal?
Your response must be concise. 0.16. What is the ratio of the Exports(as % of merchandise exports) of 1965 in Panama to that in Portugal?
Make the answer very short. 0.3. What is the ratio of the Exports(as % of merchandise exports) in 1962 in Philippines to that in Portugal?
Provide a succinct answer. 2.63. What is the ratio of the Exports(as % of merchandise exports) of 1963 in Philippines to that in Portugal?
Make the answer very short. 3.5. What is the ratio of the Exports(as % of merchandise exports) in 1964 in Philippines to that in Portugal?
Provide a succinct answer. 3.07. What is the ratio of the Exports(as % of merchandise exports) of 1965 in Philippines to that in Portugal?
Provide a short and direct response. 3.57. What is the difference between the highest and the second highest Exports(as % of merchandise exports) in 1962?
Ensure brevity in your answer.  12.24. What is the difference between the highest and the second highest Exports(as % of merchandise exports) in 1963?
Make the answer very short. 19.93. What is the difference between the highest and the second highest Exports(as % of merchandise exports) of 1964?
Your answer should be very brief. 10.69. What is the difference between the highest and the second highest Exports(as % of merchandise exports) in 1965?
Offer a very short reply. 7.85. What is the difference between the highest and the lowest Exports(as % of merchandise exports) of 1962?
Your response must be concise. 20.81. What is the difference between the highest and the lowest Exports(as % of merchandise exports) of 1963?
Offer a very short reply. 28.68. What is the difference between the highest and the lowest Exports(as % of merchandise exports) in 1964?
Offer a very short reply. 18.5. What is the difference between the highest and the lowest Exports(as % of merchandise exports) of 1965?
Provide a short and direct response. 16.93. 